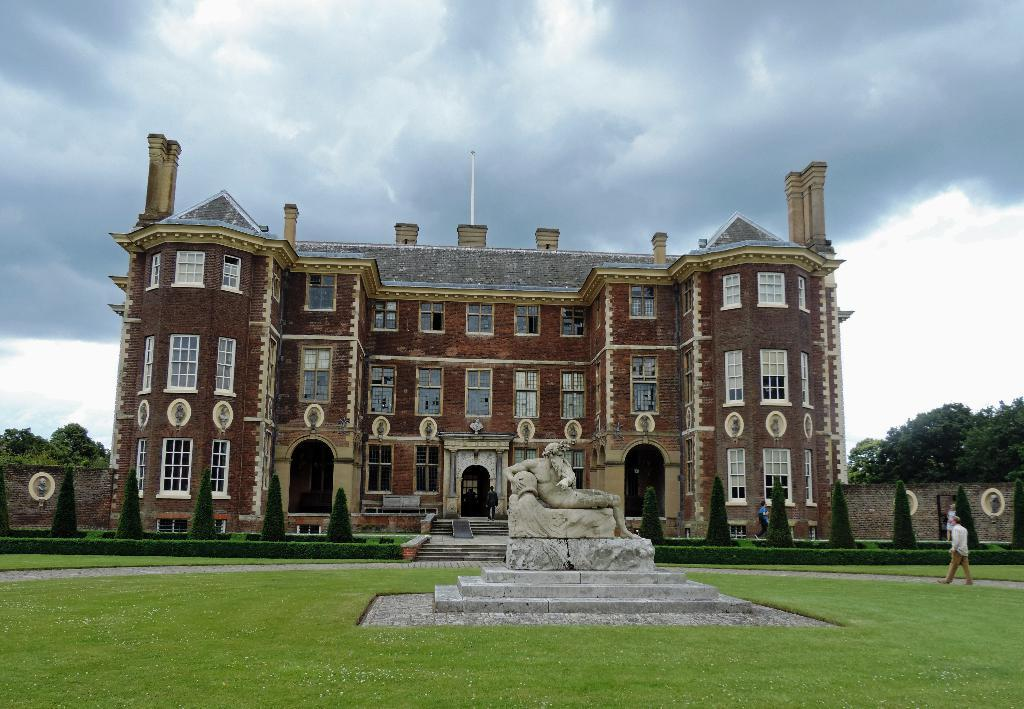What is the main subject in the image? There is a statue of a person in the image. What type of vegetation can be seen in the image? There is grass, plants, and trees in the image. Are there any people in the image? Yes, there is a group of people in the image. What type of structure is present in the image? There is a building in the image. What can be seen in the background of the image? The sky is visible in the background of the image. What type of store can be seen in the image? There is no store present in the image. What type of vacation destination is depicted in the image? There is no vacation destination depicted in the image; it features a statue, people, vegetation, a building, and the sky. 